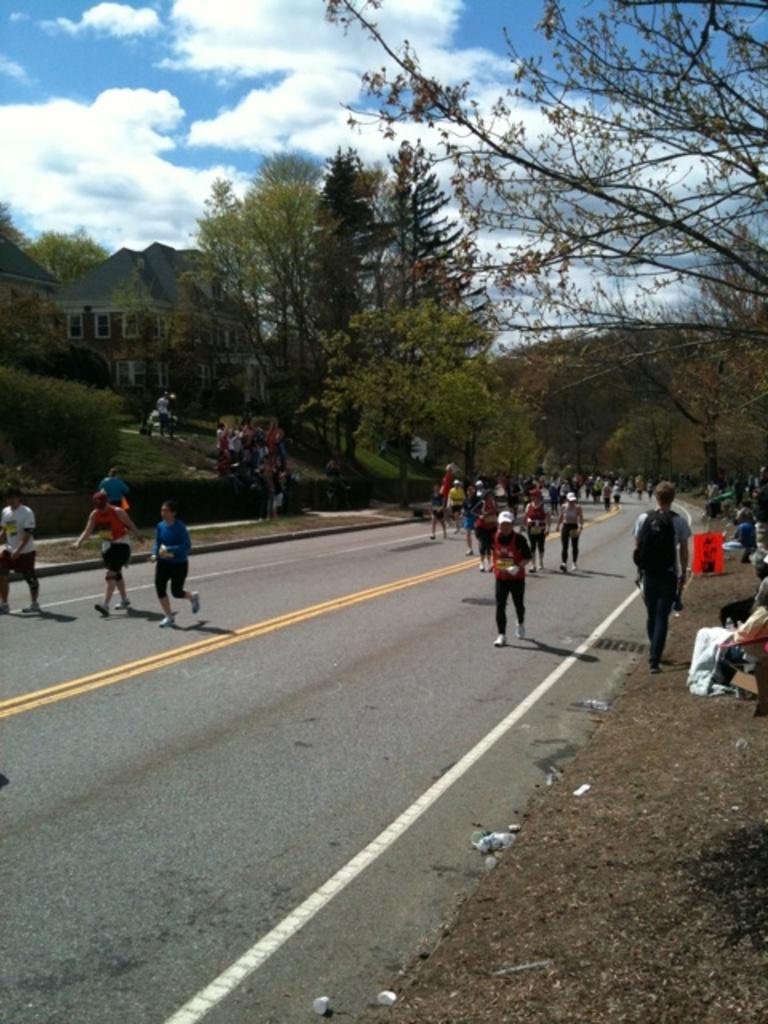What are the people in the image doing? The people in the image are walking and running on the road. What can be seen on either side of the road? There are trees on either side of the road. How many chairs are placed along the road in the image? There are no chairs present in the image. What type of pail can be seen being used by the people walking on the road? There is no pail visible in the image, and the people are not using any pails while walking or running. 